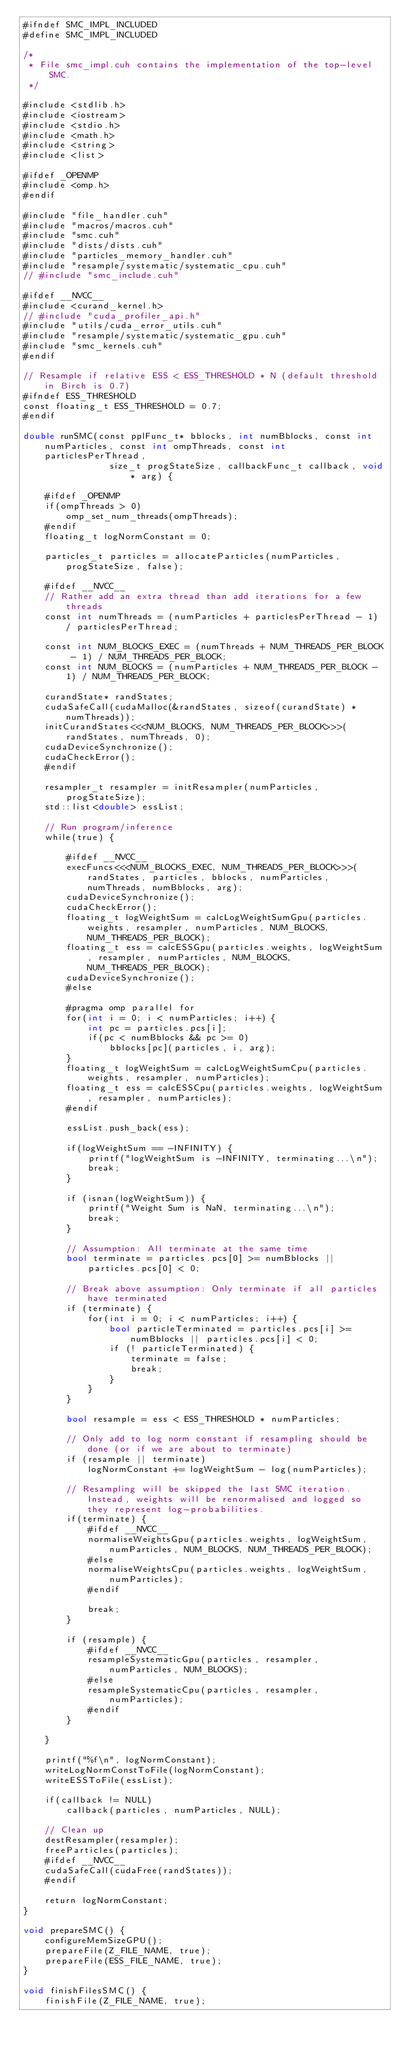Convert code to text. <code><loc_0><loc_0><loc_500><loc_500><_Cuda_>#ifndef SMC_IMPL_INCLUDED
#define SMC_IMPL_INCLUDED

/*
 * File smc_impl.cuh contains the implementation of the top-level SMC.
 */

#include <stdlib.h>
#include <iostream>
#include <stdio.h>
#include <math.h>
#include <string>
#include <list> 

#ifdef _OPENMP
#include <omp.h>
#endif

#include "file_handler.cuh"
#include "macros/macros.cuh"
#include "smc.cuh"
#include "dists/dists.cuh"
#include "particles_memory_handler.cuh"
#include "resample/systematic/systematic_cpu.cuh"
// #include "smc_include.cuh"

#ifdef __NVCC__
#include <curand_kernel.h>
// #include "cuda_profiler_api.h"
#include "utils/cuda_error_utils.cuh"
#include "resample/systematic/systematic_gpu.cuh"
#include "smc_kernels.cuh"
#endif

// Resample if relative ESS < ESS_THRESHOLD * N (default threshold in Birch is 0.7) 
#ifndef ESS_THRESHOLD
const floating_t ESS_THRESHOLD = 0.7;
#endif
 
double runSMC(const pplFunc_t* bblocks, int numBblocks, const int numParticles, const int ompThreads, const int particlesPerThread,
                size_t progStateSize, callbackFunc_t callback, void* arg) {

    #ifdef _OPENMP
    if(ompThreads > 0)
        omp_set_num_threads(ompThreads);
    #endif
    floating_t logNormConstant = 0;

    particles_t particles = allocateParticles(numParticles, progStateSize, false);
    
    #ifdef __NVCC__
    // Rather add an extra thread than add iterations for a few threads
    const int numThreads = (numParticles + particlesPerThread - 1) / particlesPerThread;

    const int NUM_BLOCKS_EXEC = (numThreads + NUM_THREADS_PER_BLOCK - 1) / NUM_THREADS_PER_BLOCK;
    const int NUM_BLOCKS = (numParticles + NUM_THREADS_PER_BLOCK - 1) / NUM_THREADS_PER_BLOCK;

    curandState* randStates;
    cudaSafeCall(cudaMalloc(&randStates, sizeof(curandState) * numThreads));
    initCurandStates<<<NUM_BLOCKS, NUM_THREADS_PER_BLOCK>>>(randStates, numThreads, 0);
    cudaDeviceSynchronize();
    cudaCheckError();
    #endif

    resampler_t resampler = initResampler(numParticles, progStateSize);
    std::list<double> essList;

    // Run program/inference
    while(true) {

        #ifdef __NVCC__
        execFuncs<<<NUM_BLOCKS_EXEC, NUM_THREADS_PER_BLOCK>>>(randStates, particles, bblocks, numParticles, numThreads, numBblocks, arg);
        cudaDeviceSynchronize();
        cudaCheckError();
        floating_t logWeightSum = calcLogWeightSumGpu(particles.weights, resampler, numParticles, NUM_BLOCKS, NUM_THREADS_PER_BLOCK);
        floating_t ess = calcESSGpu(particles.weights, logWeightSum, resampler, numParticles, NUM_BLOCKS, NUM_THREADS_PER_BLOCK);
        cudaDeviceSynchronize();
        #else

        #pragma omp parallel for
        for(int i = 0; i < numParticles; i++) {
            int pc = particles.pcs[i];
            if(pc < numBblocks && pc >= 0)
                bblocks[pc](particles, i, arg);
        }
        floating_t logWeightSum = calcLogWeightSumCpu(particles.weights, resampler, numParticles);
        floating_t ess = calcESSCpu(particles.weights, logWeightSum, resampler, numParticles);
        #endif

        essList.push_back(ess);

        if(logWeightSum == -INFINITY) {
            printf("logWeightSum is -INFINITY, terminating...\n");
            break;
        }
        
        if (isnan(logWeightSum)) {
            printf("Weight Sum is NaN, terminating...\n");
            break;
        }

        // Assumption: All terminate at the same time
        bool terminate = particles.pcs[0] >= numBblocks || particles.pcs[0] < 0;

        // Break above assumption: Only terminate if all particles have terminated
        if (terminate) {
            for(int i = 0; i < numParticles; i++) {
                bool particleTerminated = particles.pcs[i] >= numBblocks || particles.pcs[i] < 0;
                if (! particleTerminated) {
                    terminate = false;
                    break;
                }
            }
        }

        bool resample = ess < ESS_THRESHOLD * numParticles;

        // Only add to log norm constant if resampling should be done (or if we are about to terminate)
        if (resample || terminate)
            logNormConstant += logWeightSum - log(numParticles);

        // Resampling will be skipped the last SMC iteration. Instead, weights will be renormalised and logged so they represent log-probabilities.
        if(terminate) {
            #ifdef __NVCC__
            normaliseWeightsGpu(particles.weights, logWeightSum, numParticles, NUM_BLOCKS, NUM_THREADS_PER_BLOCK);
            #else
            normaliseWeightsCpu(particles.weights, logWeightSum, numParticles);
            #endif

            break;
        }
        
        if (resample) {
            #ifdef __NVCC__
            resampleSystematicGpu(particles, resampler, numParticles, NUM_BLOCKS);
            #else
            resampleSystematicCpu(particles, resampler, numParticles);
            #endif
        }
        
    }

    printf("%f\n", logNormConstant);
    writeLogNormConstToFile(logNormConstant);
    writeESSToFile(essList);

    if(callback != NULL)
        callback(particles, numParticles, NULL);

    // Clean up
    destResampler(resampler);
    freeParticles(particles);
    #ifdef __NVCC__
    cudaSafeCall(cudaFree(randStates));
    #endif

    return logNormConstant;
}

void prepareSMC() {
    configureMemSizeGPU();
    prepareFile(Z_FILE_NAME, true);
    prepareFile(ESS_FILE_NAME, true);
}

void finishFilesSMC() {
    finishFile(Z_FILE_NAME, true);</code> 